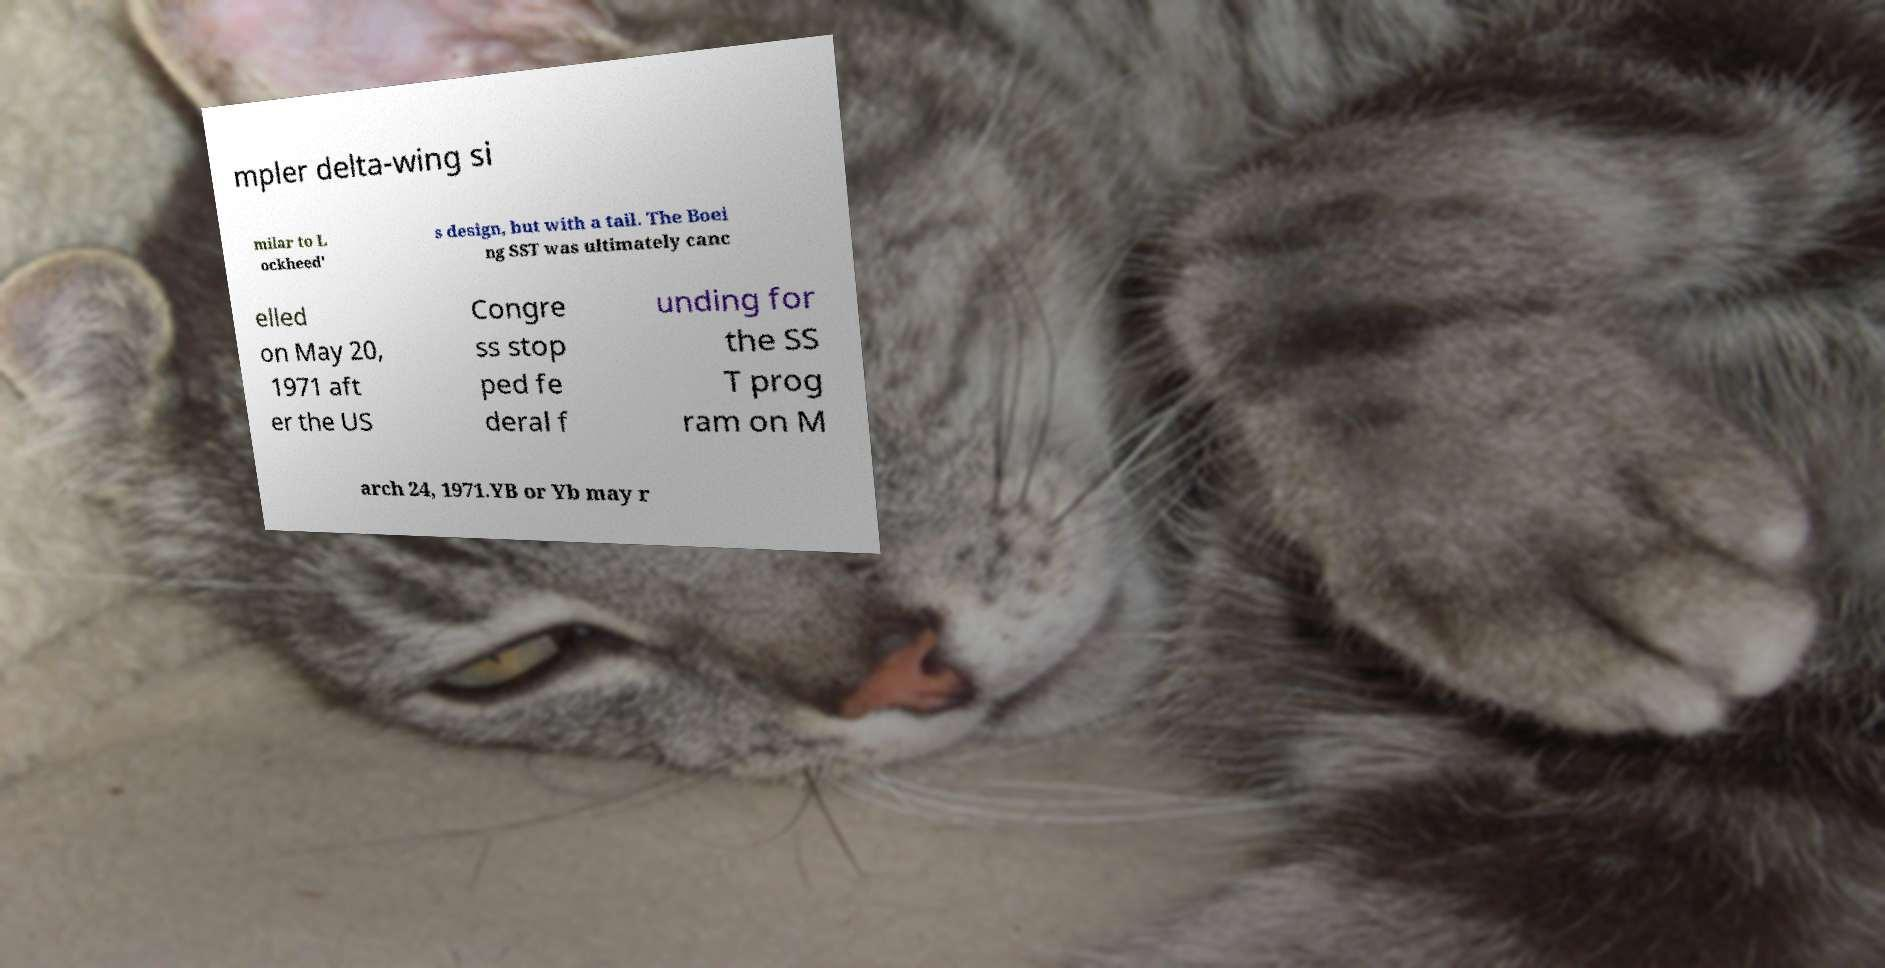Please identify and transcribe the text found in this image. mpler delta-wing si milar to L ockheed' s design, but with a tail. The Boei ng SST was ultimately canc elled on May 20, 1971 aft er the US Congre ss stop ped fe deral f unding for the SS T prog ram on M arch 24, 1971.YB or Yb may r 